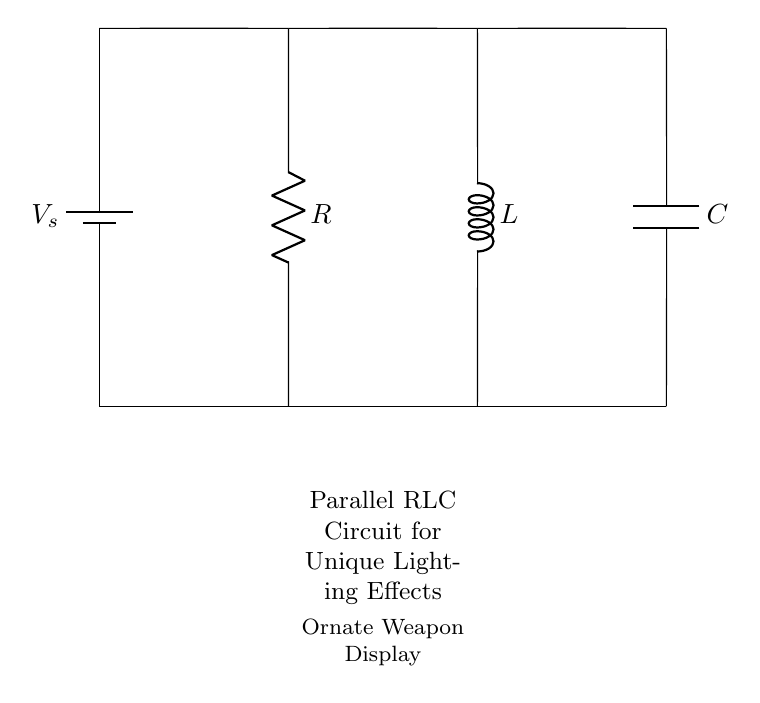What type of circuit is shown? The circuit diagram depicts a parallel RLC circuit, indicated by the arrangement of the resistor, inductor, and capacitor connected in parallel to the source voltage.
Answer: Parallel RLC circuit What does the resistor represent? The resistor in this circuit represents the resistance element, which dissipates energy as heat and helps control the current flow. It is labeled with R in the diagram.
Answer: Resistance What component stores energy in a magnetic field? The inductor, labeled L in the circuit, stores energy in its magnetic field when current passes through it, which is a key characteristic of inductors.
Answer: Inductor What is the main purpose of the capacitor in this circuit? The capacitor, labeled C, stores electrical energy in an electric field and can release it, which contributes to the timing and lighting effects sought in the weapon display.
Answer: To store electrical energy How do resistors affect the total current in a parallel RLC circuit? In a parallel RLC circuit, the total current is the sum of the currents through each branch. The resistor allows for a specific amount of current, affecting the overall circuit behavior.
Answer: It divides total current What happens to the impedance as frequency increases in a parallel RLC circuit? As frequency increases, the impedance of the circuit changes due to the behavior of the capacitor and inductor; the inductive reactance increases while capacitive reactance decreases. This affects the overall impedance of the circuit at varying frequencies.
Answer: Impedance decreases What is the function of this parallel RLC circuit in the context of ornate weapon displays? The parallel RLC circuit in this context is designed to create unique lighting effects by controlling the timing and brightness of the lights through the combination of resistance, inductance, and capacitance.
Answer: To create lighting effects 